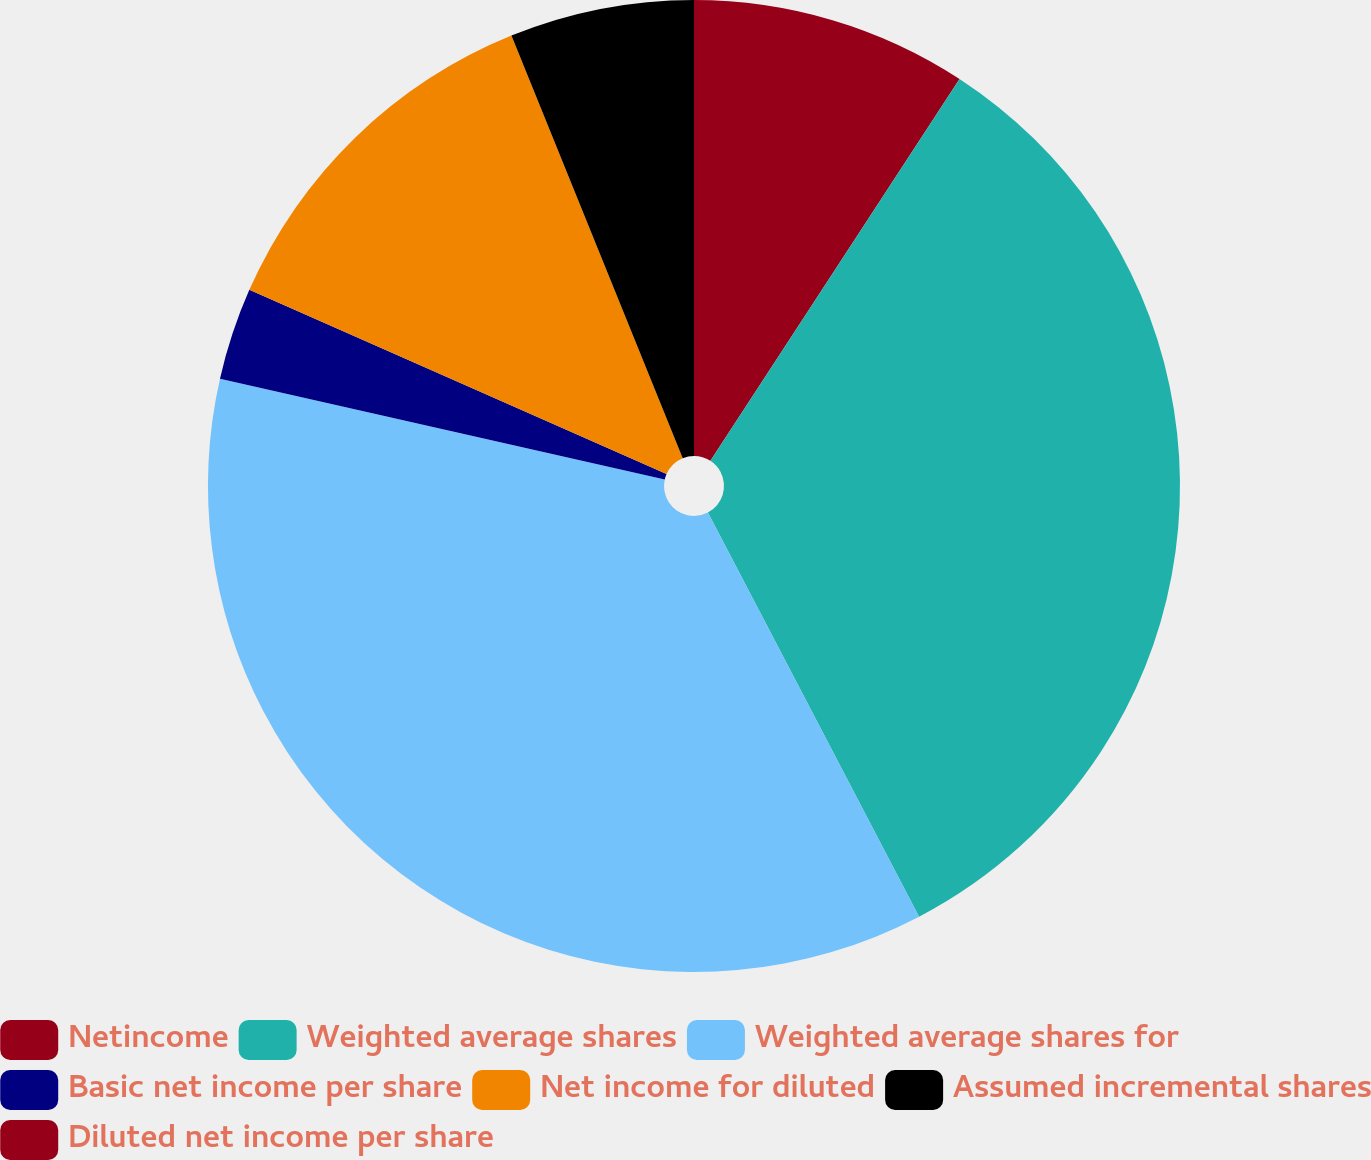Convert chart. <chart><loc_0><loc_0><loc_500><loc_500><pie_chart><fcel>Netincome<fcel>Weighted average shares<fcel>Weighted average shares for<fcel>Basic net income per share<fcel>Net income for diluted<fcel>Assumed incremental shares<fcel>Diluted net income per share<nl><fcel>9.2%<fcel>33.14%<fcel>36.21%<fcel>3.07%<fcel>12.26%<fcel>6.13%<fcel>0.0%<nl></chart> 